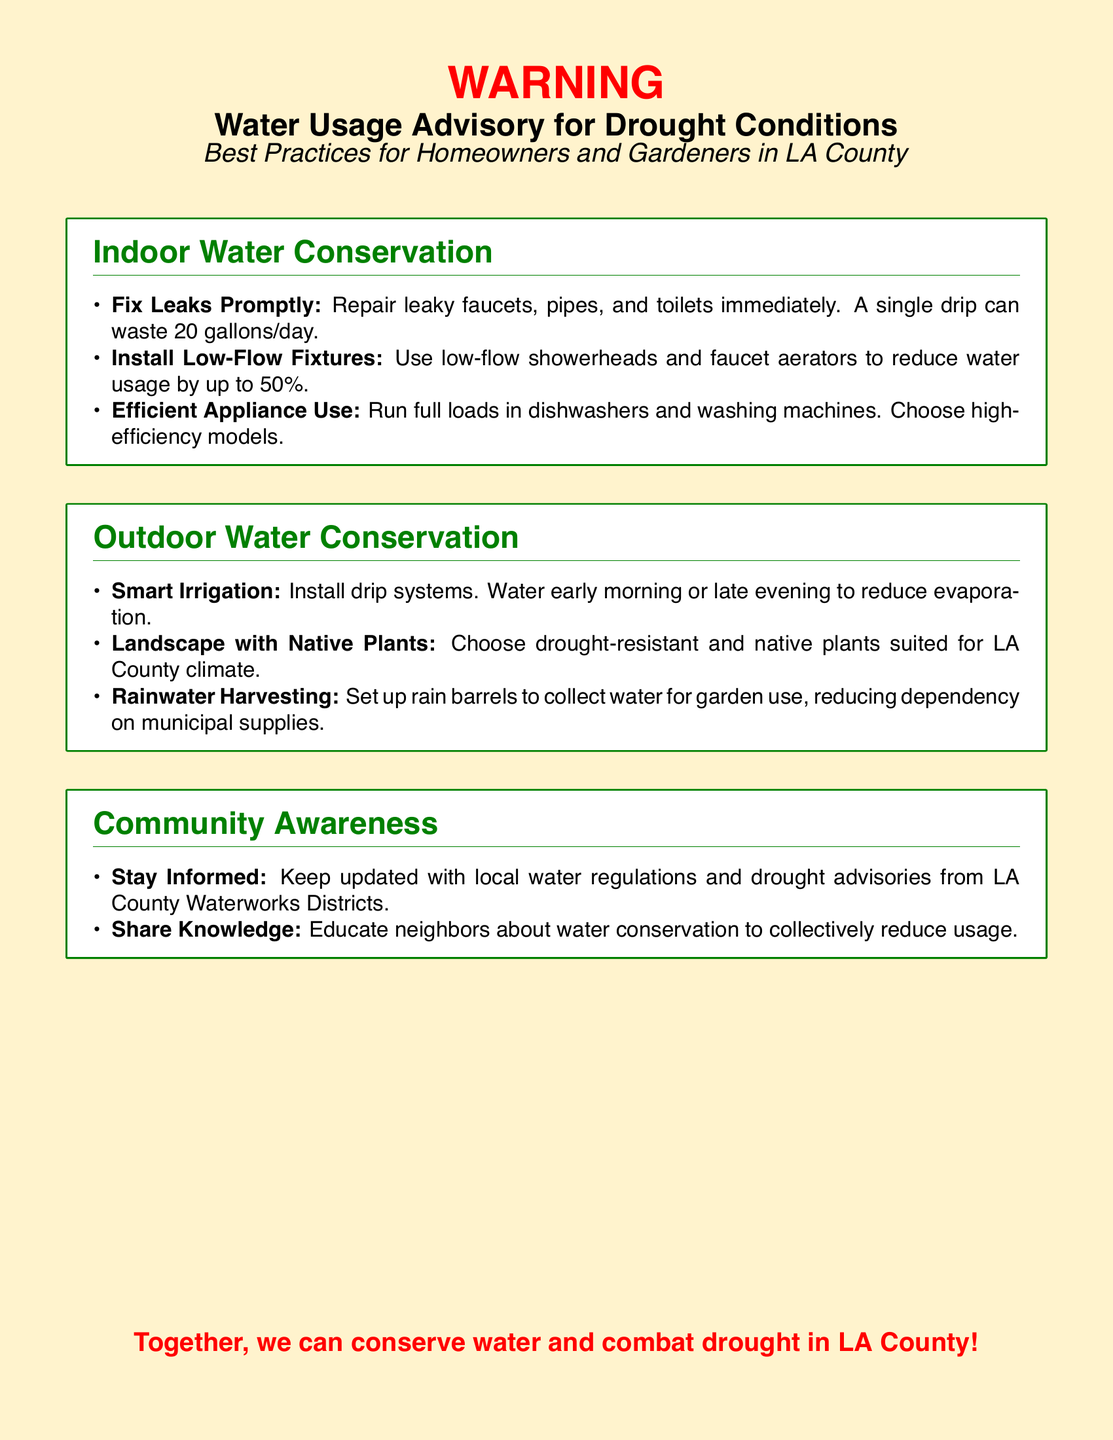What is the main purpose of the document? The main purpose of the document is to provide a Water Usage Advisory for Drought Conditions in LA County along with best practices for homeowners and gardeners.
Answer: Water Usage Advisory for Drought Conditions How many gallons can a single drip waste in a day? The document states that a single drip can waste 20 gallons per day.
Answer: 20 gallons What percentage can low-flow fixtures reduce water usage by? The text mentions that low-flow fixtures can reduce water usage by up to 50 percent.
Answer: 50 percent What is a recommended time to water plants to reduce evaporation? The document suggests watering early morning or late evening to reduce evaporation.
Answer: Early morning or late evening What type of plants should homeowners choose for drought resistance? The best plants to choose are drought-resistant and native plants suited for LA County's climate.
Answer: Drought-resistant and native plants What system can be installed for smart irrigation? Homeowners are advised to install drip systems for smart irrigation.
Answer: Drip systems How can rainwater harvesting help with water usage? Setting up rain barrels allows homeowners to collect water for garden use, thereby reducing dependence on municipal supplies.
Answer: Collect water for garden use What action should individuals take to stay informed about drought regulations? The document advises keeping updated with local water regulations and drought advisories from LA County Waterworks Districts.
Answer: Stay updated with local water regulations What is the significance of community awareness in water conservation? The document emphasizes the importance of educating neighbors about water conservation to collectively reduce usage.
Answer: Educate neighbors about water conservation 